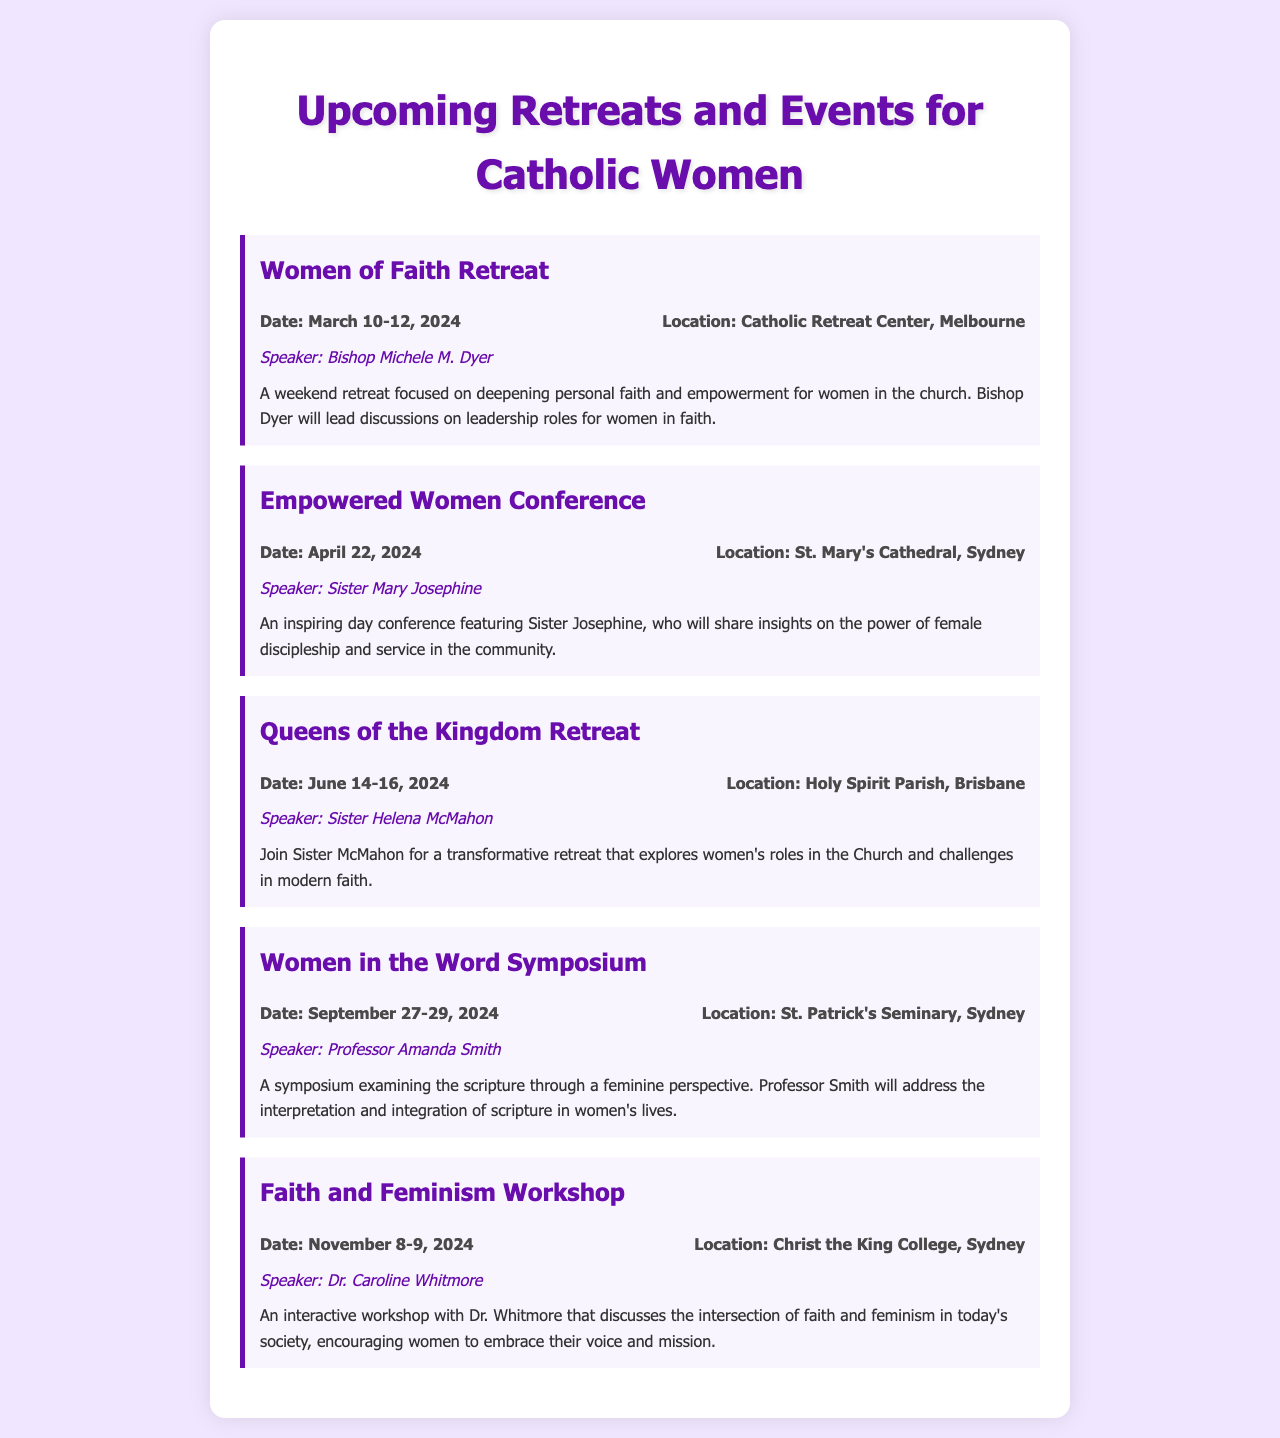What is the date of the Women of Faith Retreat? The date of the Women of Faith Retreat is specified in the document as March 10-12, 2024.
Answer: March 10-12, 2024 Who is the speaker for the Empowered Women Conference? The speaker for the Empowered Women Conference is mentioned in the document as Sister Mary Josephine.
Answer: Sister Mary Josephine Where is the Queens of the Kingdom Retreat being held? The location for the Queens of the Kingdom Retreat is detailed in the document as Holy Spirit Parish, Brisbane.
Answer: Holy Spirit Parish, Brisbane What is the main topic of the Women in the Word Symposium? The document states that the Women in the Word Symposium examines scripture through a feminine perspective.
Answer: Scripture through a feminine perspective When is the Faith and Feminism Workshop scheduled? The document provides the date for the Faith and Feminism Workshop as November 8-9, 2024.
Answer: November 8-9, 2024 Who will be speaking at the Women of Faith Retreat? The speaker for the Women of Faith Retreat is noted in the document as Bishop Michele M. Dyer.
Answer: Bishop Michele M. Dyer What is the focus of the Faith and Feminism Workshop? The focus of the Faith and Feminism Workshop is described in the document as the intersection of faith and feminism.
Answer: Intersection of faith and feminism Which event features a discussion on leadership roles for women in faith? The Women of Faith Retreat is specified in the document to include discussions on leadership roles for women in faith.
Answer: Women of Faith Retreat What is the duration of the Queens of the Kingdom Retreat? The document indicates that the duration of the Queens of the Kingdom Retreat is from June 14-16, 2024.
Answer: June 14-16, 2024 